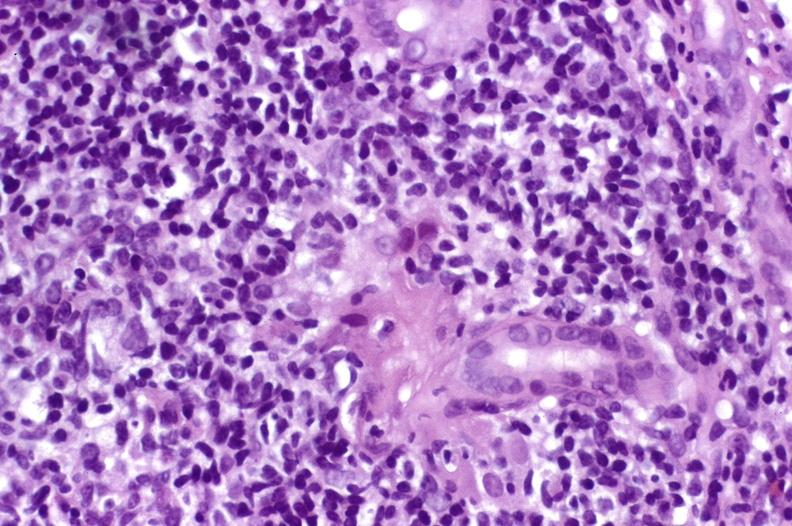does close-up tumor show recurrent hepatitis c virus?
Answer the question using a single word or phrase. No 